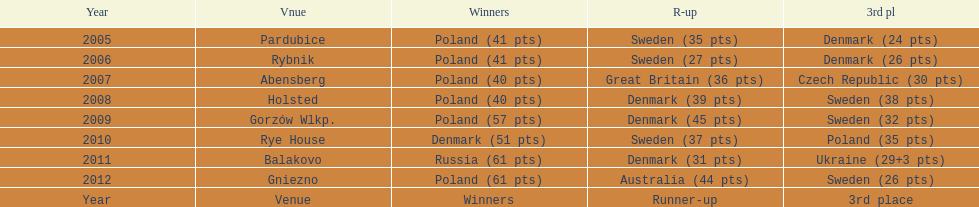What is the total number of points earned in the years 2009? 134. 